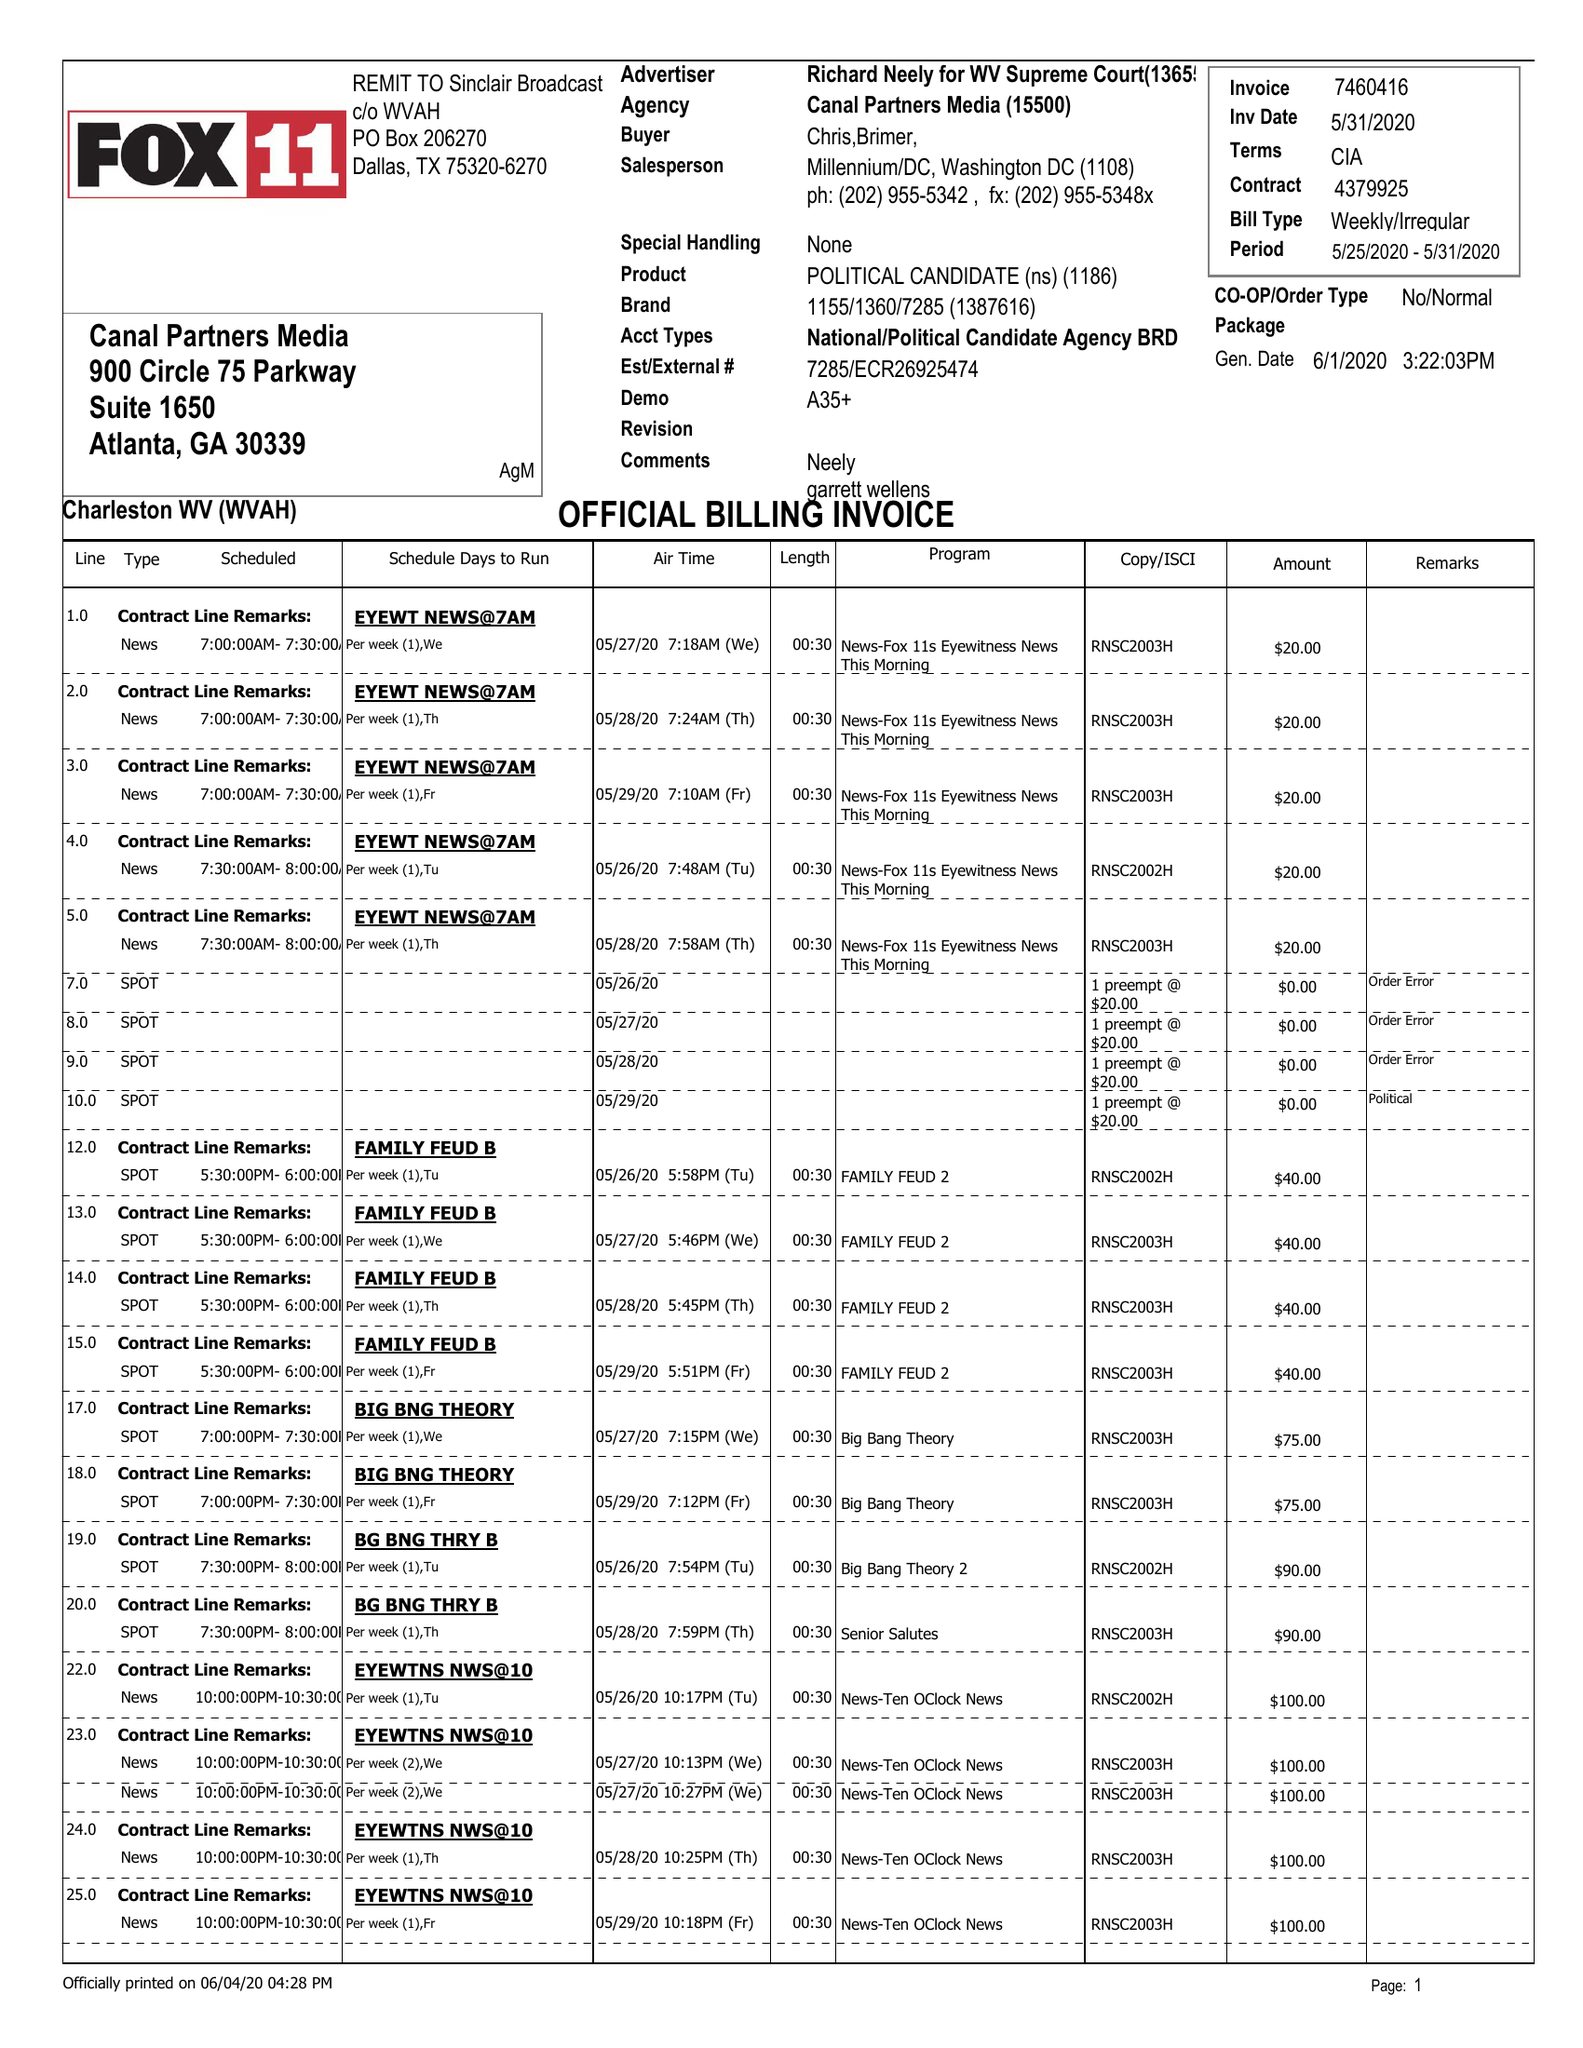What is the value for the advertiser?
Answer the question using a single word or phrase. RICHARD NEELY FOR WV SUPREME COURT 